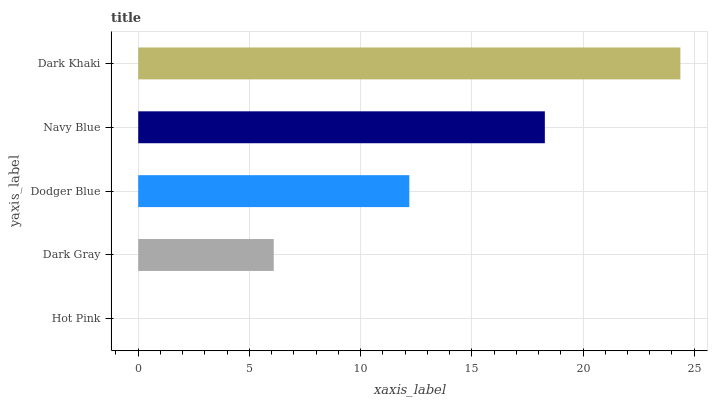Is Hot Pink the minimum?
Answer yes or no. Yes. Is Dark Khaki the maximum?
Answer yes or no. Yes. Is Dark Gray the minimum?
Answer yes or no. No. Is Dark Gray the maximum?
Answer yes or no. No. Is Dark Gray greater than Hot Pink?
Answer yes or no. Yes. Is Hot Pink less than Dark Gray?
Answer yes or no. Yes. Is Hot Pink greater than Dark Gray?
Answer yes or no. No. Is Dark Gray less than Hot Pink?
Answer yes or no. No. Is Dodger Blue the high median?
Answer yes or no. Yes. Is Dodger Blue the low median?
Answer yes or no. Yes. Is Dark Khaki the high median?
Answer yes or no. No. Is Navy Blue the low median?
Answer yes or no. No. 